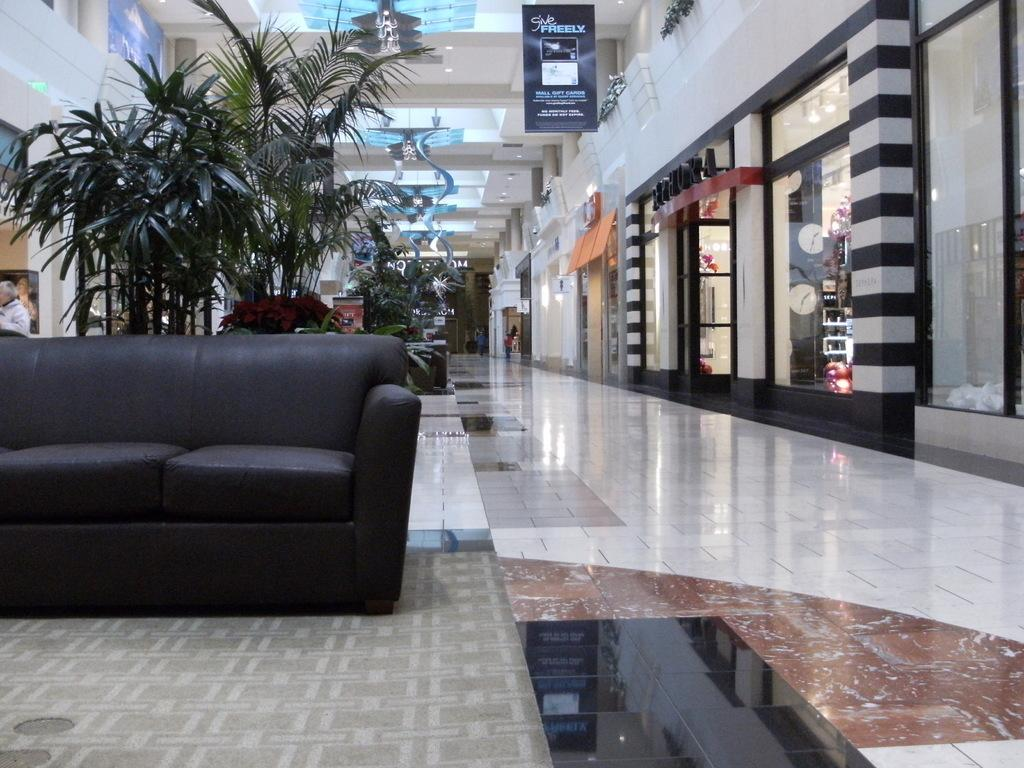What type of furniture is in the image? There is a couch in the image. What can be seen in the background of the image? There is a plant, stores, and a wall visible in the background of the image. What type of door is in the image? There is a glass door in the image. What additional decoration or signage is present in the image? There is a banner in the image. Can you see any fangs on the couch in the image? There are no fangs present in the image; it features a couch and other objects. Is there a scarecrow visible in the image? There is no scarecrow present in the image. 